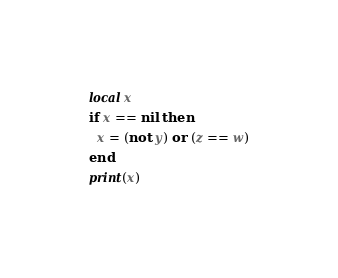<code> <loc_0><loc_0><loc_500><loc_500><_Lua_>local x
if x == nil then
  x = (not y) or (z == w)
end
print(x)</code> 